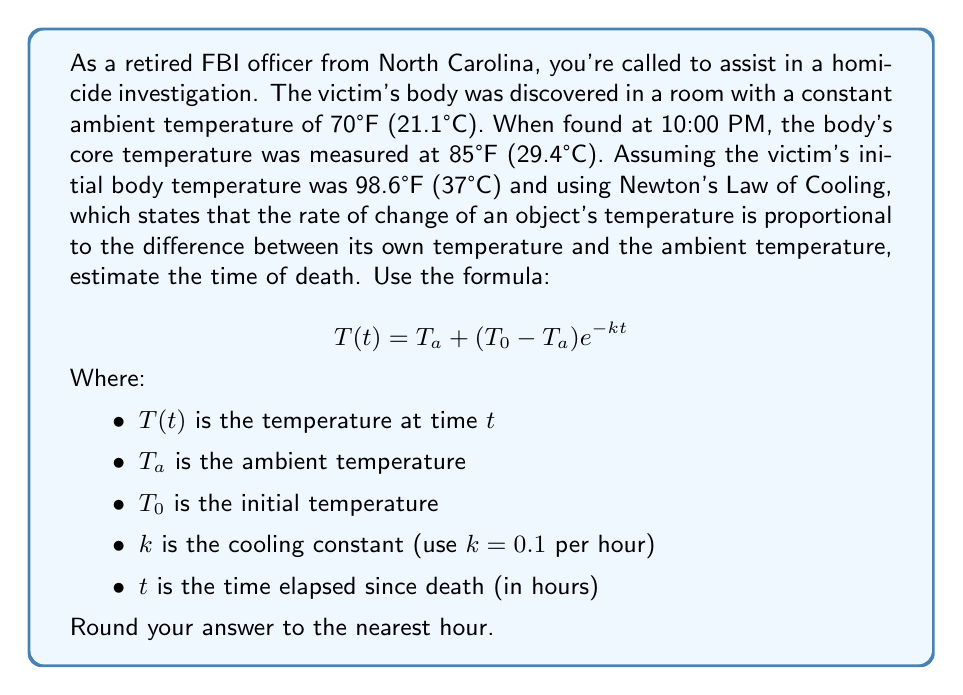Help me with this question. To solve this problem, we'll use the given formula and the information provided:

$$T(t) = T_a + (T_0 - T_a)e^{-kt}$$

Where:
$T(t) = 85°F$ (temperature when found)
$T_a = 70°F$ (ambient temperature)
$T_0 = 98.6°F$ (initial body temperature)
$k = 0.1$ per hour

Let's substitute these values into the equation:

$$85 = 70 + (98.6 - 70)e^{-0.1t}$$

Now, let's solve for $t$:

1) Subtract 70 from both sides:
   $$15 = 28.6e^{-0.1t}$$

2) Divide both sides by 28.6:
   $$\frac{15}{28.6} = e^{-0.1t}$$

3) Take the natural log of both sides:
   $$\ln(\frac{15}{28.6}) = -0.1t$$

4) Divide both sides by -0.1:
   $$\frac{\ln(\frac{15}{28.6})}{-0.1} = t$$

5) Calculate the value:
   $$t \approx 6.4 \text{ hours}$$

6) Round to the nearest hour:
   $$t \approx 6 \text{ hours}$$

Therefore, the estimated time of death was about 6 hours before the body was found at 10:00 PM.
Answer: The estimated time of death is 4:00 PM (6 hours before the body was discovered at 10:00 PM). 